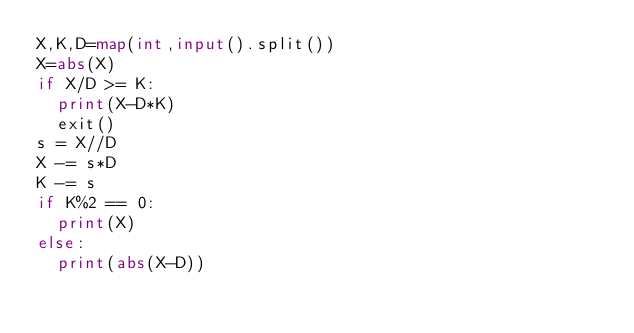Convert code to text. <code><loc_0><loc_0><loc_500><loc_500><_Python_>X,K,D=map(int,input().split())
X=abs(X)
if X/D >= K:
  print(X-D*K)
  exit()
s = X//D
X -= s*D
K -= s
if K%2 == 0:
  print(X)
else:
  print(abs(X-D))</code> 